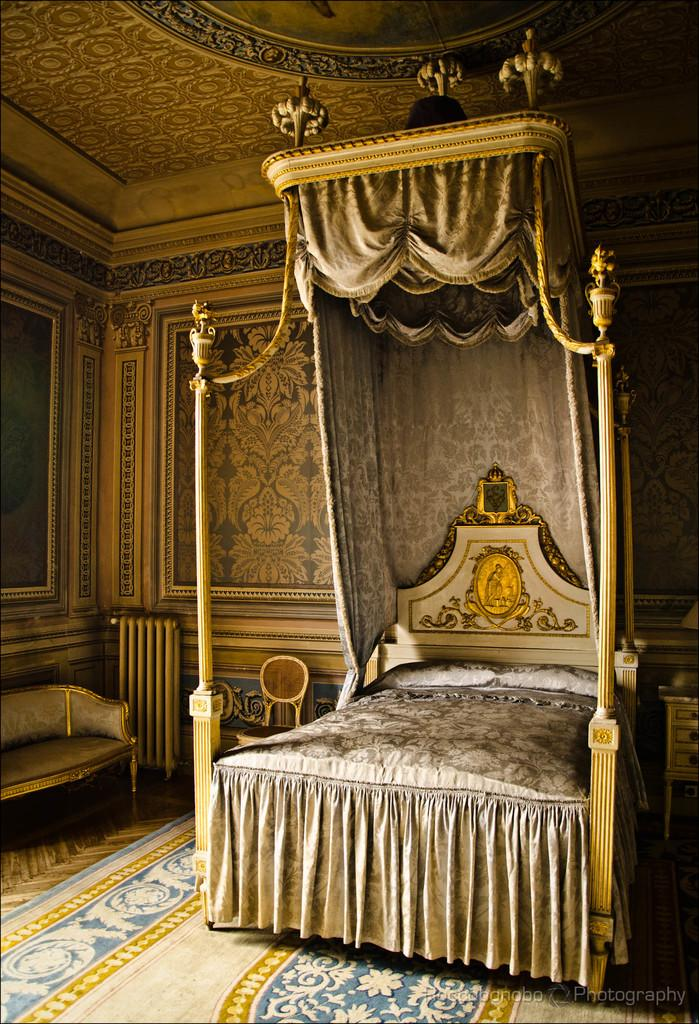What type of furniture is in the image? There is a bed, a sofa, and a chair in the image. What is on the bed? The bed has two pillows and a blanket on it. What is on the floor? The floor has a carpet. How are the walls decorated? The walls are designed. What type of vein is visible on the chair in the image? There are no veins visible on the chair in the image. What is the reason for the design on the walls in the image? The reason for the design on the walls is not mentioned in the image, so it cannot be determined. 